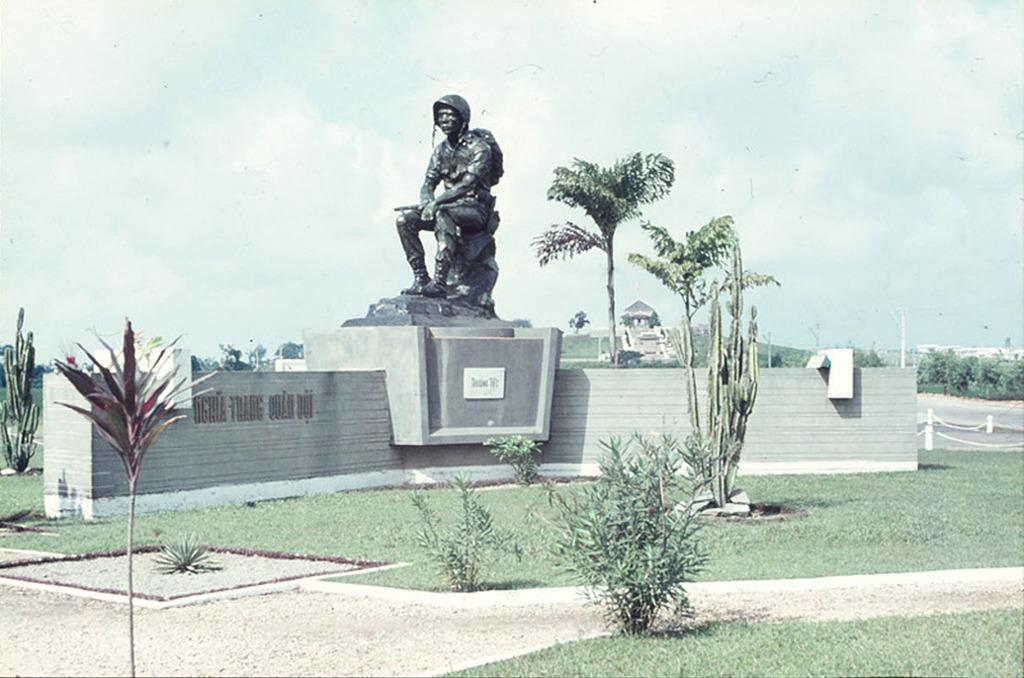What type of vegetation can be seen in the image? There are plants, grass, and trees in the image. What is the main feature in the foreground of the image? There is a statue in the image. What can be seen in the background of the image? There are buildings in the background of the image. What is visible at the top of the image? The sky is visible at the top of the image. Can you see a heart-shaped straw in the image? There is no heart-shaped straw present in the image. Is there a squirrel sitting on the statue in the image? There is no squirrel visible in the image; only the statue and vegetation are present. 